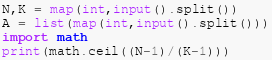<code> <loc_0><loc_0><loc_500><loc_500><_Python_>N,K = map(int,input().split())
A = list(map(int,input().split()))
import math
print(math.ceil((N-1)/(K-1)))</code> 